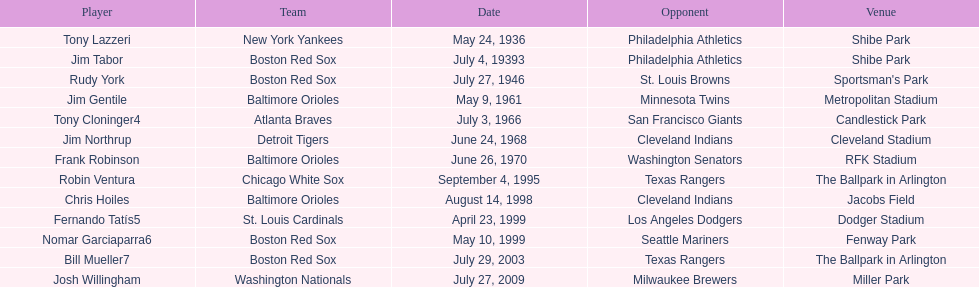What was the name of the player who accomplished this in 1999 but played for the boston red sox? Nomar Garciaparra. Help me parse the entirety of this table. {'header': ['Player', 'Team', 'Date', 'Opponent', 'Venue'], 'rows': [['Tony Lazzeri', 'New York Yankees', 'May 24, 1936', 'Philadelphia Athletics', 'Shibe Park'], ['Jim Tabor', 'Boston Red Sox', 'July 4, 19393', 'Philadelphia Athletics', 'Shibe Park'], ['Rudy York', 'Boston Red Sox', 'July 27, 1946', 'St. Louis Browns', "Sportsman's Park"], ['Jim Gentile', 'Baltimore Orioles', 'May 9, 1961', 'Minnesota Twins', 'Metropolitan Stadium'], ['Tony Cloninger4', 'Atlanta Braves', 'July 3, 1966', 'San Francisco Giants', 'Candlestick Park'], ['Jim Northrup', 'Detroit Tigers', 'June 24, 1968', 'Cleveland Indians', 'Cleveland Stadium'], ['Frank Robinson', 'Baltimore Orioles', 'June 26, 1970', 'Washington Senators', 'RFK Stadium'], ['Robin Ventura', 'Chicago White Sox', 'September 4, 1995', 'Texas Rangers', 'The Ballpark in Arlington'], ['Chris Hoiles', 'Baltimore Orioles', 'August 14, 1998', 'Cleveland Indians', 'Jacobs Field'], ['Fernando Tatís5', 'St. Louis Cardinals', 'April 23, 1999', 'Los Angeles Dodgers', 'Dodger Stadium'], ['Nomar Garciaparra6', 'Boston Red Sox', 'May 10, 1999', 'Seattle Mariners', 'Fenway Park'], ['Bill Mueller7', 'Boston Red Sox', 'July 29, 2003', 'Texas Rangers', 'The Ballpark in Arlington'], ['Josh Willingham', 'Washington Nationals', 'July 27, 2009', 'Milwaukee Brewers', 'Miller Park']]} 